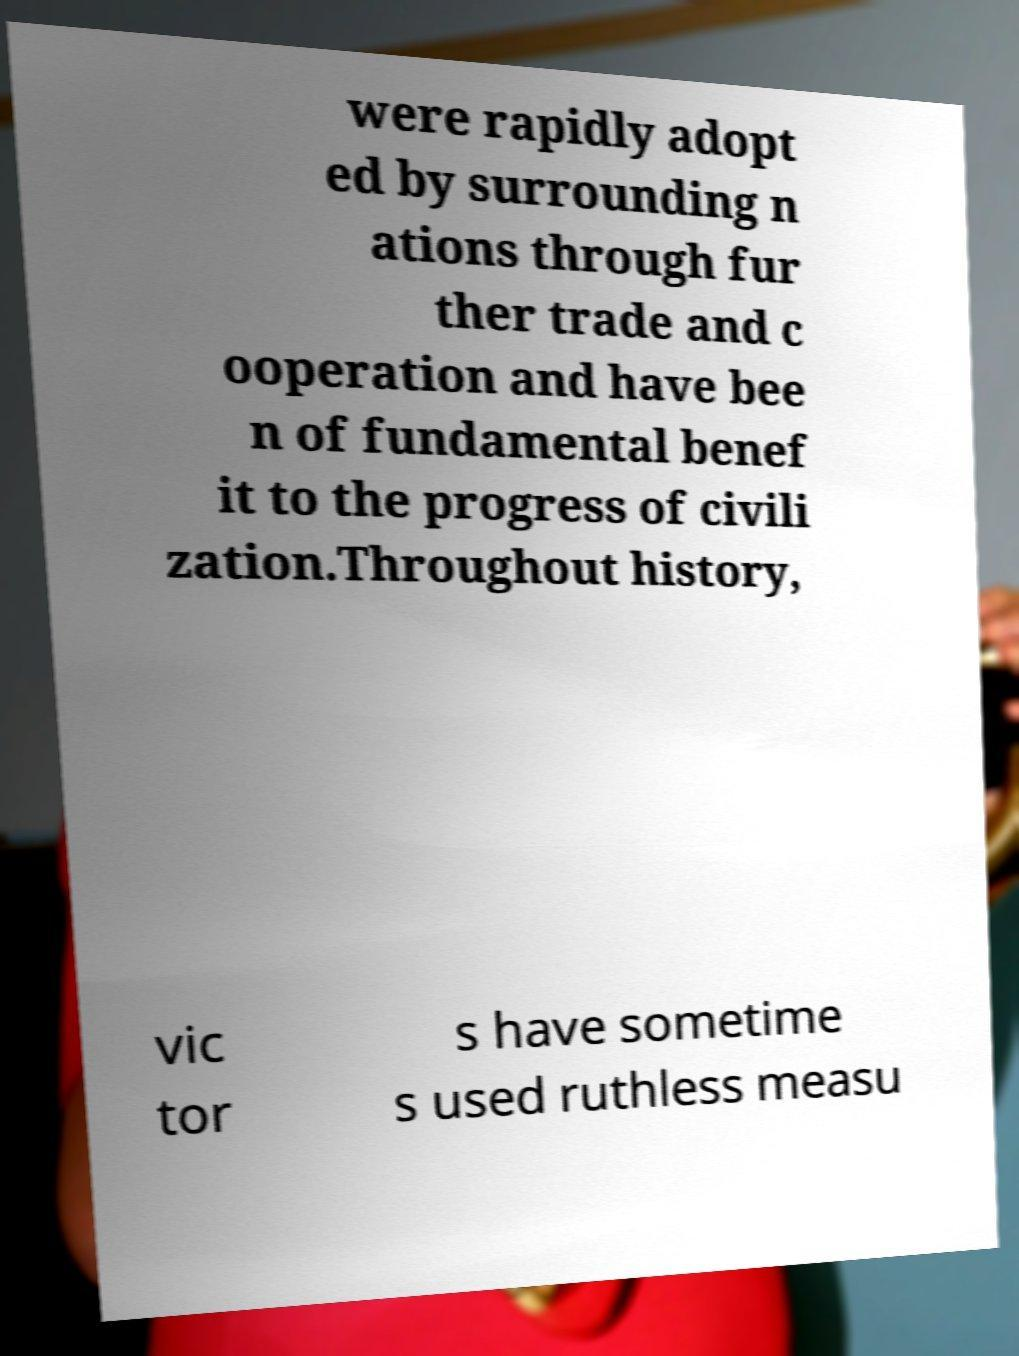Could you assist in decoding the text presented in this image and type it out clearly? were rapidly adopt ed by surrounding n ations through fur ther trade and c ooperation and have bee n of fundamental benef it to the progress of civili zation.Throughout history, vic tor s have sometime s used ruthless measu 